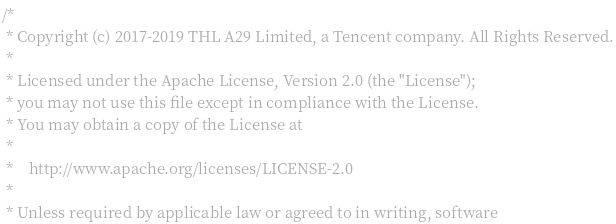Convert code to text. <code><loc_0><loc_0><loc_500><loc_500><_C++_>/*
 * Copyright (c) 2017-2019 THL A29 Limited, a Tencent company. All Rights Reserved.
 *
 * Licensed under the Apache License, Version 2.0 (the "License");
 * you may not use this file except in compliance with the License.
 * You may obtain a copy of the License at
 *
 *    http://www.apache.org/licenses/LICENSE-2.0
 *
 * Unless required by applicable law or agreed to in writing, software</code> 